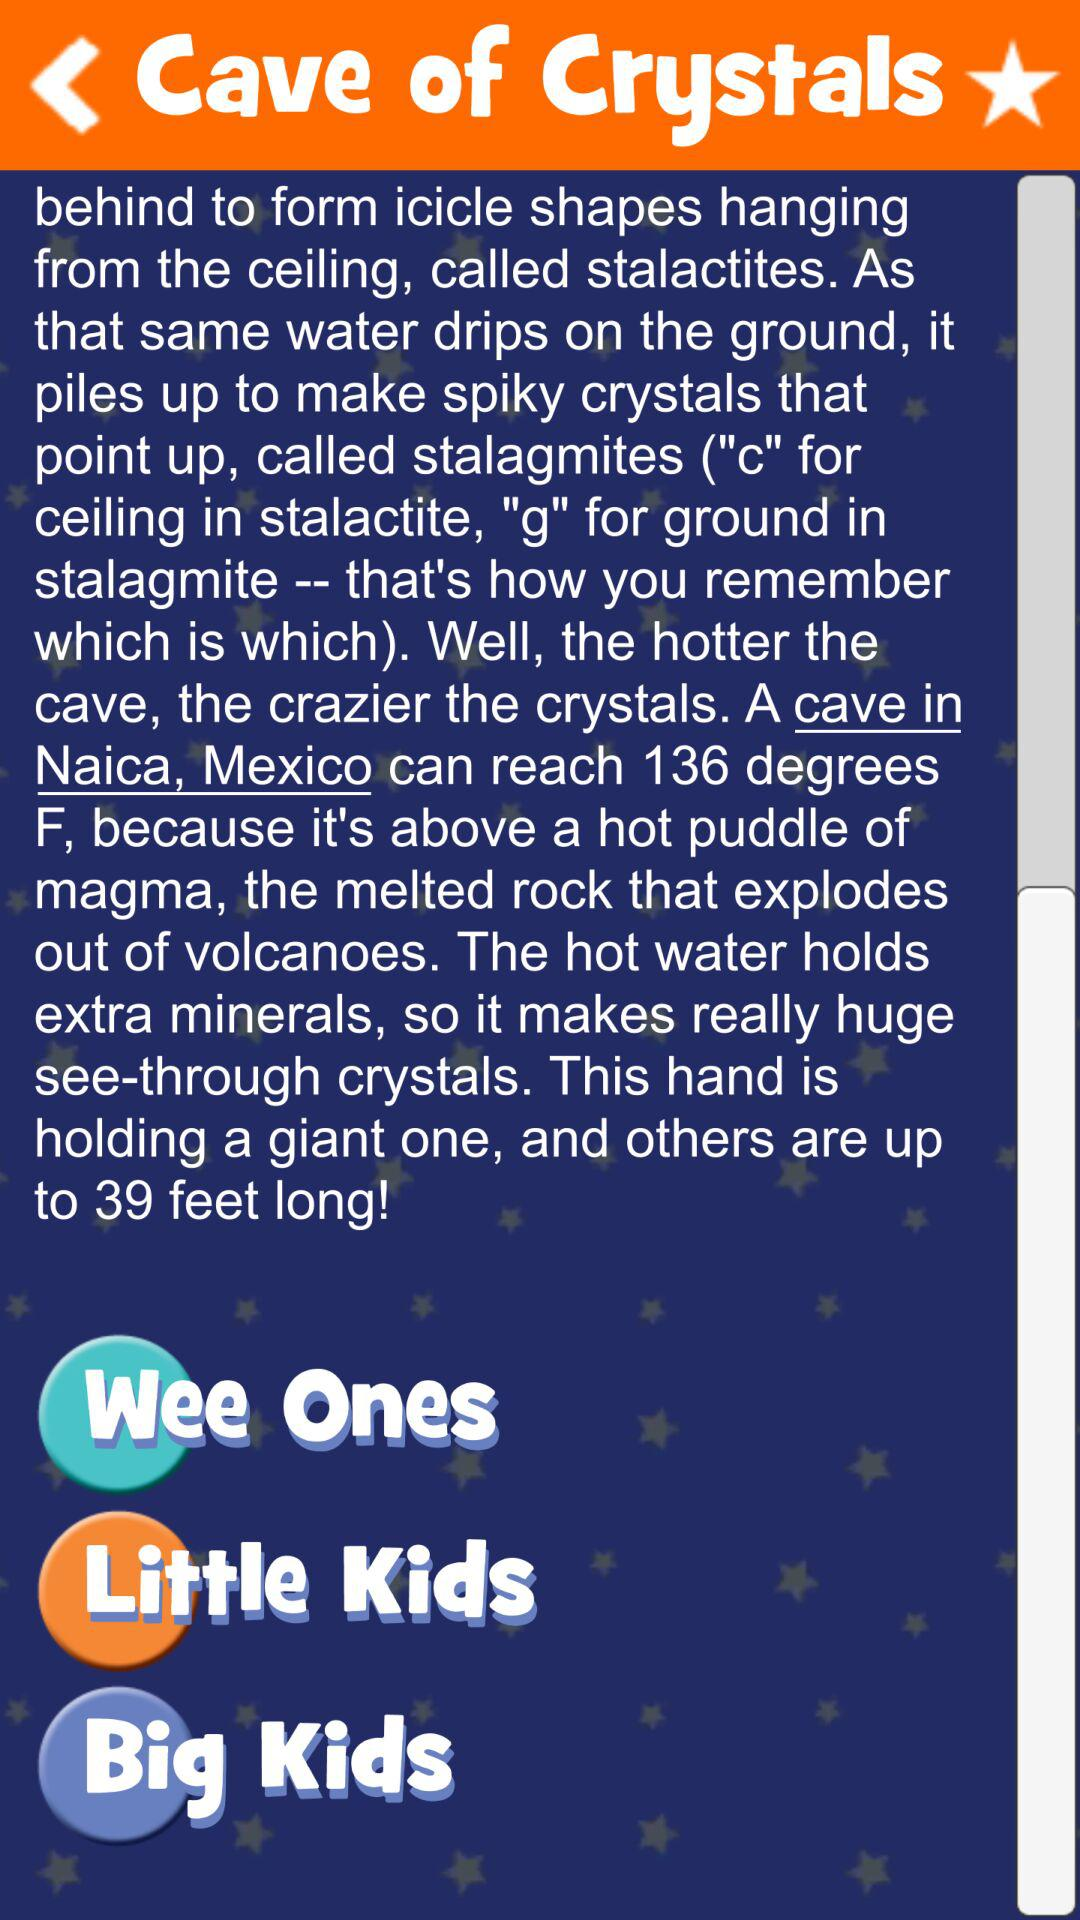How many feet longer is the longest crystal than the hand holding it?
Answer the question using a single word or phrase. 39 